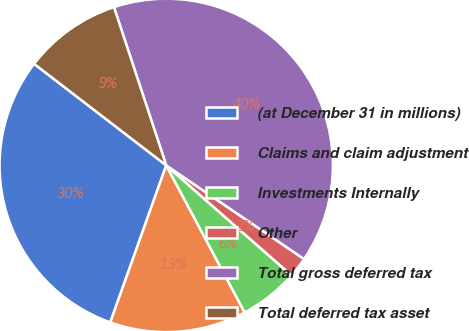Convert chart. <chart><loc_0><loc_0><loc_500><loc_500><pie_chart><fcel>(at December 31 in millions)<fcel>Claims and claim adjustment<fcel>Investments Internally<fcel>Other<fcel>Total gross deferred tax<fcel>Total deferred tax asset<nl><fcel>29.98%<fcel>13.25%<fcel>5.73%<fcel>1.97%<fcel>39.58%<fcel>9.49%<nl></chart> 